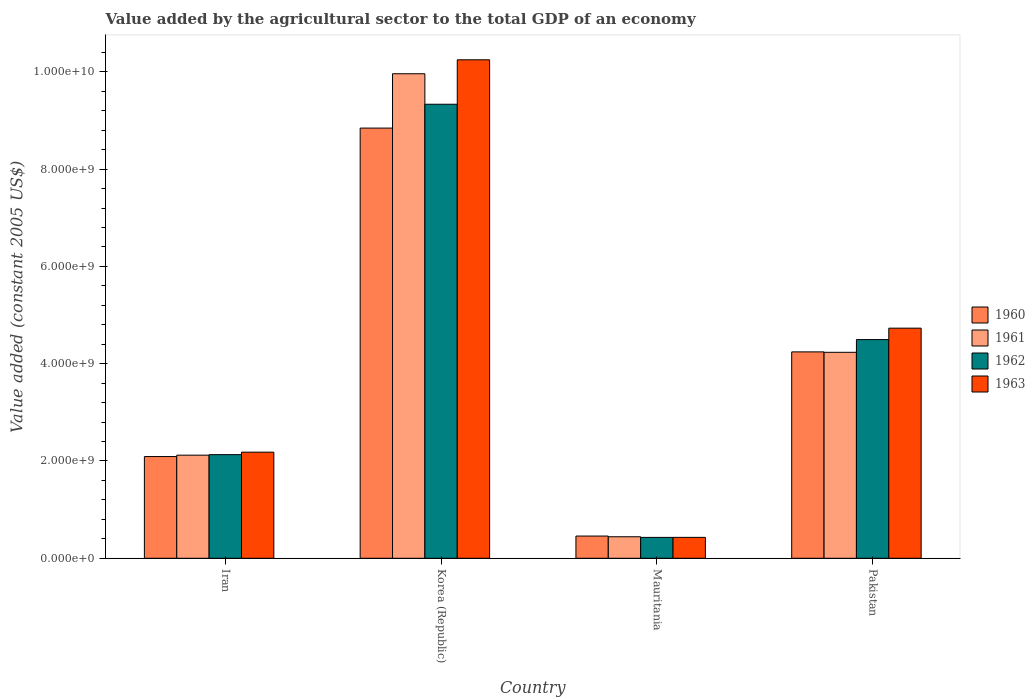Are the number of bars per tick equal to the number of legend labels?
Your answer should be compact. Yes. Are the number of bars on each tick of the X-axis equal?
Your answer should be very brief. Yes. How many bars are there on the 3rd tick from the left?
Give a very brief answer. 4. What is the value added by the agricultural sector in 1961 in Korea (Republic)?
Provide a succinct answer. 9.96e+09. Across all countries, what is the maximum value added by the agricultural sector in 1963?
Your response must be concise. 1.02e+1. Across all countries, what is the minimum value added by the agricultural sector in 1961?
Your answer should be very brief. 4.42e+08. In which country was the value added by the agricultural sector in 1963 minimum?
Give a very brief answer. Mauritania. What is the total value added by the agricultural sector in 1961 in the graph?
Make the answer very short. 1.68e+1. What is the difference between the value added by the agricultural sector in 1962 in Korea (Republic) and that in Mauritania?
Make the answer very short. 8.91e+09. What is the difference between the value added by the agricultural sector in 1962 in Pakistan and the value added by the agricultural sector in 1960 in Iran?
Your answer should be very brief. 2.40e+09. What is the average value added by the agricultural sector in 1960 per country?
Give a very brief answer. 3.91e+09. What is the difference between the value added by the agricultural sector of/in 1960 and value added by the agricultural sector of/in 1961 in Mauritania?
Make the answer very short. 1.44e+07. What is the ratio of the value added by the agricultural sector in 1960 in Korea (Republic) to that in Pakistan?
Your answer should be compact. 2.08. Is the difference between the value added by the agricultural sector in 1960 in Iran and Mauritania greater than the difference between the value added by the agricultural sector in 1961 in Iran and Mauritania?
Offer a very short reply. No. What is the difference between the highest and the second highest value added by the agricultural sector in 1963?
Your answer should be compact. 5.52e+09. What is the difference between the highest and the lowest value added by the agricultural sector in 1961?
Your response must be concise. 9.52e+09. In how many countries, is the value added by the agricultural sector in 1962 greater than the average value added by the agricultural sector in 1962 taken over all countries?
Keep it short and to the point. 2. Is the sum of the value added by the agricultural sector in 1962 in Iran and Mauritania greater than the maximum value added by the agricultural sector in 1963 across all countries?
Make the answer very short. No. Is it the case that in every country, the sum of the value added by the agricultural sector in 1960 and value added by the agricultural sector in 1961 is greater than the sum of value added by the agricultural sector in 1962 and value added by the agricultural sector in 1963?
Offer a very short reply. No. Is it the case that in every country, the sum of the value added by the agricultural sector in 1961 and value added by the agricultural sector in 1962 is greater than the value added by the agricultural sector in 1963?
Your response must be concise. Yes. How many bars are there?
Your answer should be compact. 16. What is the difference between two consecutive major ticks on the Y-axis?
Provide a succinct answer. 2.00e+09. Are the values on the major ticks of Y-axis written in scientific E-notation?
Provide a short and direct response. Yes. Does the graph contain any zero values?
Ensure brevity in your answer.  No. Does the graph contain grids?
Ensure brevity in your answer.  No. How are the legend labels stacked?
Keep it short and to the point. Vertical. What is the title of the graph?
Keep it short and to the point. Value added by the agricultural sector to the total GDP of an economy. Does "1967" appear as one of the legend labels in the graph?
Make the answer very short. No. What is the label or title of the Y-axis?
Your answer should be compact. Value added (constant 2005 US$). What is the Value added (constant 2005 US$) in 1960 in Iran?
Offer a very short reply. 2.09e+09. What is the Value added (constant 2005 US$) of 1961 in Iran?
Provide a short and direct response. 2.12e+09. What is the Value added (constant 2005 US$) of 1962 in Iran?
Give a very brief answer. 2.13e+09. What is the Value added (constant 2005 US$) of 1963 in Iran?
Offer a terse response. 2.18e+09. What is the Value added (constant 2005 US$) in 1960 in Korea (Republic)?
Keep it short and to the point. 8.84e+09. What is the Value added (constant 2005 US$) in 1961 in Korea (Republic)?
Ensure brevity in your answer.  9.96e+09. What is the Value added (constant 2005 US$) in 1962 in Korea (Republic)?
Offer a very short reply. 9.33e+09. What is the Value added (constant 2005 US$) in 1963 in Korea (Republic)?
Ensure brevity in your answer.  1.02e+1. What is the Value added (constant 2005 US$) in 1960 in Mauritania?
Your answer should be compact. 4.57e+08. What is the Value added (constant 2005 US$) of 1961 in Mauritania?
Keep it short and to the point. 4.42e+08. What is the Value added (constant 2005 US$) of 1962 in Mauritania?
Keep it short and to the point. 4.29e+08. What is the Value added (constant 2005 US$) of 1963 in Mauritania?
Offer a very short reply. 4.30e+08. What is the Value added (constant 2005 US$) of 1960 in Pakistan?
Provide a succinct answer. 4.24e+09. What is the Value added (constant 2005 US$) in 1961 in Pakistan?
Provide a short and direct response. 4.23e+09. What is the Value added (constant 2005 US$) in 1962 in Pakistan?
Offer a terse response. 4.50e+09. What is the Value added (constant 2005 US$) of 1963 in Pakistan?
Provide a short and direct response. 4.73e+09. Across all countries, what is the maximum Value added (constant 2005 US$) in 1960?
Ensure brevity in your answer.  8.84e+09. Across all countries, what is the maximum Value added (constant 2005 US$) of 1961?
Provide a succinct answer. 9.96e+09. Across all countries, what is the maximum Value added (constant 2005 US$) in 1962?
Provide a succinct answer. 9.33e+09. Across all countries, what is the maximum Value added (constant 2005 US$) of 1963?
Provide a short and direct response. 1.02e+1. Across all countries, what is the minimum Value added (constant 2005 US$) in 1960?
Give a very brief answer. 4.57e+08. Across all countries, what is the minimum Value added (constant 2005 US$) in 1961?
Provide a succinct answer. 4.42e+08. Across all countries, what is the minimum Value added (constant 2005 US$) of 1962?
Your answer should be very brief. 4.29e+08. Across all countries, what is the minimum Value added (constant 2005 US$) of 1963?
Your answer should be very brief. 4.30e+08. What is the total Value added (constant 2005 US$) in 1960 in the graph?
Provide a succinct answer. 1.56e+1. What is the total Value added (constant 2005 US$) in 1961 in the graph?
Your answer should be compact. 1.68e+1. What is the total Value added (constant 2005 US$) of 1962 in the graph?
Give a very brief answer. 1.64e+1. What is the total Value added (constant 2005 US$) of 1963 in the graph?
Ensure brevity in your answer.  1.76e+1. What is the difference between the Value added (constant 2005 US$) in 1960 in Iran and that in Korea (Republic)?
Make the answer very short. -6.75e+09. What is the difference between the Value added (constant 2005 US$) of 1961 in Iran and that in Korea (Republic)?
Give a very brief answer. -7.84e+09. What is the difference between the Value added (constant 2005 US$) of 1962 in Iran and that in Korea (Republic)?
Offer a terse response. -7.20e+09. What is the difference between the Value added (constant 2005 US$) of 1963 in Iran and that in Korea (Republic)?
Provide a short and direct response. -8.07e+09. What is the difference between the Value added (constant 2005 US$) of 1960 in Iran and that in Mauritania?
Make the answer very short. 1.63e+09. What is the difference between the Value added (constant 2005 US$) of 1961 in Iran and that in Mauritania?
Offer a terse response. 1.68e+09. What is the difference between the Value added (constant 2005 US$) of 1962 in Iran and that in Mauritania?
Make the answer very short. 1.70e+09. What is the difference between the Value added (constant 2005 US$) of 1963 in Iran and that in Mauritania?
Provide a short and direct response. 1.75e+09. What is the difference between the Value added (constant 2005 US$) in 1960 in Iran and that in Pakistan?
Make the answer very short. -2.15e+09. What is the difference between the Value added (constant 2005 US$) of 1961 in Iran and that in Pakistan?
Ensure brevity in your answer.  -2.11e+09. What is the difference between the Value added (constant 2005 US$) in 1962 in Iran and that in Pakistan?
Your response must be concise. -2.37e+09. What is the difference between the Value added (constant 2005 US$) of 1963 in Iran and that in Pakistan?
Your answer should be compact. -2.55e+09. What is the difference between the Value added (constant 2005 US$) in 1960 in Korea (Republic) and that in Mauritania?
Make the answer very short. 8.39e+09. What is the difference between the Value added (constant 2005 US$) of 1961 in Korea (Republic) and that in Mauritania?
Your answer should be compact. 9.52e+09. What is the difference between the Value added (constant 2005 US$) in 1962 in Korea (Republic) and that in Mauritania?
Make the answer very short. 8.91e+09. What is the difference between the Value added (constant 2005 US$) in 1963 in Korea (Republic) and that in Mauritania?
Give a very brief answer. 9.82e+09. What is the difference between the Value added (constant 2005 US$) of 1960 in Korea (Republic) and that in Pakistan?
Your answer should be very brief. 4.60e+09. What is the difference between the Value added (constant 2005 US$) in 1961 in Korea (Republic) and that in Pakistan?
Offer a terse response. 5.73e+09. What is the difference between the Value added (constant 2005 US$) of 1962 in Korea (Republic) and that in Pakistan?
Keep it short and to the point. 4.84e+09. What is the difference between the Value added (constant 2005 US$) of 1963 in Korea (Republic) and that in Pakistan?
Keep it short and to the point. 5.52e+09. What is the difference between the Value added (constant 2005 US$) of 1960 in Mauritania and that in Pakistan?
Ensure brevity in your answer.  -3.79e+09. What is the difference between the Value added (constant 2005 US$) in 1961 in Mauritania and that in Pakistan?
Your answer should be very brief. -3.79e+09. What is the difference between the Value added (constant 2005 US$) of 1962 in Mauritania and that in Pakistan?
Your response must be concise. -4.07e+09. What is the difference between the Value added (constant 2005 US$) in 1963 in Mauritania and that in Pakistan?
Give a very brief answer. -4.30e+09. What is the difference between the Value added (constant 2005 US$) of 1960 in Iran and the Value added (constant 2005 US$) of 1961 in Korea (Republic)?
Provide a succinct answer. -7.87e+09. What is the difference between the Value added (constant 2005 US$) of 1960 in Iran and the Value added (constant 2005 US$) of 1962 in Korea (Republic)?
Offer a terse response. -7.24e+09. What is the difference between the Value added (constant 2005 US$) of 1960 in Iran and the Value added (constant 2005 US$) of 1963 in Korea (Republic)?
Your answer should be very brief. -8.16e+09. What is the difference between the Value added (constant 2005 US$) in 1961 in Iran and the Value added (constant 2005 US$) in 1962 in Korea (Republic)?
Your response must be concise. -7.21e+09. What is the difference between the Value added (constant 2005 US$) in 1961 in Iran and the Value added (constant 2005 US$) in 1963 in Korea (Republic)?
Ensure brevity in your answer.  -8.13e+09. What is the difference between the Value added (constant 2005 US$) in 1962 in Iran and the Value added (constant 2005 US$) in 1963 in Korea (Republic)?
Your answer should be very brief. -8.12e+09. What is the difference between the Value added (constant 2005 US$) in 1960 in Iran and the Value added (constant 2005 US$) in 1961 in Mauritania?
Your answer should be very brief. 1.65e+09. What is the difference between the Value added (constant 2005 US$) in 1960 in Iran and the Value added (constant 2005 US$) in 1962 in Mauritania?
Offer a terse response. 1.66e+09. What is the difference between the Value added (constant 2005 US$) of 1960 in Iran and the Value added (constant 2005 US$) of 1963 in Mauritania?
Make the answer very short. 1.66e+09. What is the difference between the Value added (constant 2005 US$) in 1961 in Iran and the Value added (constant 2005 US$) in 1962 in Mauritania?
Your answer should be very brief. 1.69e+09. What is the difference between the Value added (constant 2005 US$) in 1961 in Iran and the Value added (constant 2005 US$) in 1963 in Mauritania?
Your response must be concise. 1.69e+09. What is the difference between the Value added (constant 2005 US$) in 1962 in Iran and the Value added (constant 2005 US$) in 1963 in Mauritania?
Offer a terse response. 1.70e+09. What is the difference between the Value added (constant 2005 US$) in 1960 in Iran and the Value added (constant 2005 US$) in 1961 in Pakistan?
Give a very brief answer. -2.14e+09. What is the difference between the Value added (constant 2005 US$) of 1960 in Iran and the Value added (constant 2005 US$) of 1962 in Pakistan?
Give a very brief answer. -2.40e+09. What is the difference between the Value added (constant 2005 US$) in 1960 in Iran and the Value added (constant 2005 US$) in 1963 in Pakistan?
Offer a very short reply. -2.64e+09. What is the difference between the Value added (constant 2005 US$) of 1961 in Iran and the Value added (constant 2005 US$) of 1962 in Pakistan?
Your answer should be compact. -2.38e+09. What is the difference between the Value added (constant 2005 US$) in 1961 in Iran and the Value added (constant 2005 US$) in 1963 in Pakistan?
Your response must be concise. -2.61e+09. What is the difference between the Value added (constant 2005 US$) of 1962 in Iran and the Value added (constant 2005 US$) of 1963 in Pakistan?
Provide a short and direct response. -2.60e+09. What is the difference between the Value added (constant 2005 US$) in 1960 in Korea (Republic) and the Value added (constant 2005 US$) in 1961 in Mauritania?
Your answer should be compact. 8.40e+09. What is the difference between the Value added (constant 2005 US$) of 1960 in Korea (Republic) and the Value added (constant 2005 US$) of 1962 in Mauritania?
Your answer should be compact. 8.41e+09. What is the difference between the Value added (constant 2005 US$) in 1960 in Korea (Republic) and the Value added (constant 2005 US$) in 1963 in Mauritania?
Keep it short and to the point. 8.41e+09. What is the difference between the Value added (constant 2005 US$) in 1961 in Korea (Republic) and the Value added (constant 2005 US$) in 1962 in Mauritania?
Your answer should be very brief. 9.53e+09. What is the difference between the Value added (constant 2005 US$) in 1961 in Korea (Republic) and the Value added (constant 2005 US$) in 1963 in Mauritania?
Your response must be concise. 9.53e+09. What is the difference between the Value added (constant 2005 US$) in 1962 in Korea (Republic) and the Value added (constant 2005 US$) in 1963 in Mauritania?
Your answer should be very brief. 8.90e+09. What is the difference between the Value added (constant 2005 US$) of 1960 in Korea (Republic) and the Value added (constant 2005 US$) of 1961 in Pakistan?
Provide a succinct answer. 4.61e+09. What is the difference between the Value added (constant 2005 US$) in 1960 in Korea (Republic) and the Value added (constant 2005 US$) in 1962 in Pakistan?
Offer a very short reply. 4.35e+09. What is the difference between the Value added (constant 2005 US$) of 1960 in Korea (Republic) and the Value added (constant 2005 US$) of 1963 in Pakistan?
Provide a succinct answer. 4.11e+09. What is the difference between the Value added (constant 2005 US$) of 1961 in Korea (Republic) and the Value added (constant 2005 US$) of 1962 in Pakistan?
Your answer should be very brief. 5.46e+09. What is the difference between the Value added (constant 2005 US$) in 1961 in Korea (Republic) and the Value added (constant 2005 US$) in 1963 in Pakistan?
Provide a succinct answer. 5.23e+09. What is the difference between the Value added (constant 2005 US$) of 1962 in Korea (Republic) and the Value added (constant 2005 US$) of 1963 in Pakistan?
Offer a very short reply. 4.60e+09. What is the difference between the Value added (constant 2005 US$) in 1960 in Mauritania and the Value added (constant 2005 US$) in 1961 in Pakistan?
Provide a succinct answer. -3.78e+09. What is the difference between the Value added (constant 2005 US$) of 1960 in Mauritania and the Value added (constant 2005 US$) of 1962 in Pakistan?
Keep it short and to the point. -4.04e+09. What is the difference between the Value added (constant 2005 US$) of 1960 in Mauritania and the Value added (constant 2005 US$) of 1963 in Pakistan?
Offer a terse response. -4.27e+09. What is the difference between the Value added (constant 2005 US$) in 1961 in Mauritania and the Value added (constant 2005 US$) in 1962 in Pakistan?
Provide a succinct answer. -4.05e+09. What is the difference between the Value added (constant 2005 US$) in 1961 in Mauritania and the Value added (constant 2005 US$) in 1963 in Pakistan?
Your answer should be very brief. -4.29e+09. What is the difference between the Value added (constant 2005 US$) of 1962 in Mauritania and the Value added (constant 2005 US$) of 1963 in Pakistan?
Make the answer very short. -4.30e+09. What is the average Value added (constant 2005 US$) of 1960 per country?
Your answer should be very brief. 3.91e+09. What is the average Value added (constant 2005 US$) in 1961 per country?
Give a very brief answer. 4.19e+09. What is the average Value added (constant 2005 US$) of 1962 per country?
Offer a very short reply. 4.10e+09. What is the average Value added (constant 2005 US$) of 1963 per country?
Offer a very short reply. 4.40e+09. What is the difference between the Value added (constant 2005 US$) of 1960 and Value added (constant 2005 US$) of 1961 in Iran?
Your answer should be very brief. -2.84e+07. What is the difference between the Value added (constant 2005 US$) in 1960 and Value added (constant 2005 US$) in 1962 in Iran?
Give a very brief answer. -3.89e+07. What is the difference between the Value added (constant 2005 US$) of 1960 and Value added (constant 2005 US$) of 1963 in Iran?
Your response must be concise. -9.02e+07. What is the difference between the Value added (constant 2005 US$) in 1961 and Value added (constant 2005 US$) in 1962 in Iran?
Your answer should be compact. -1.05e+07. What is the difference between the Value added (constant 2005 US$) of 1961 and Value added (constant 2005 US$) of 1963 in Iran?
Ensure brevity in your answer.  -6.18e+07. What is the difference between the Value added (constant 2005 US$) in 1962 and Value added (constant 2005 US$) in 1963 in Iran?
Make the answer very short. -5.13e+07. What is the difference between the Value added (constant 2005 US$) in 1960 and Value added (constant 2005 US$) in 1961 in Korea (Republic)?
Your answer should be very brief. -1.12e+09. What is the difference between the Value added (constant 2005 US$) of 1960 and Value added (constant 2005 US$) of 1962 in Korea (Republic)?
Offer a very short reply. -4.90e+08. What is the difference between the Value added (constant 2005 US$) in 1960 and Value added (constant 2005 US$) in 1963 in Korea (Republic)?
Provide a succinct answer. -1.40e+09. What is the difference between the Value added (constant 2005 US$) in 1961 and Value added (constant 2005 US$) in 1962 in Korea (Republic)?
Your answer should be very brief. 6.27e+08. What is the difference between the Value added (constant 2005 US$) in 1961 and Value added (constant 2005 US$) in 1963 in Korea (Republic)?
Your answer should be compact. -2.87e+08. What is the difference between the Value added (constant 2005 US$) in 1962 and Value added (constant 2005 US$) in 1963 in Korea (Republic)?
Keep it short and to the point. -9.14e+08. What is the difference between the Value added (constant 2005 US$) of 1960 and Value added (constant 2005 US$) of 1961 in Mauritania?
Provide a succinct answer. 1.44e+07. What is the difference between the Value added (constant 2005 US$) of 1960 and Value added (constant 2005 US$) of 1962 in Mauritania?
Offer a terse response. 2.75e+07. What is the difference between the Value added (constant 2005 US$) in 1960 and Value added (constant 2005 US$) in 1963 in Mauritania?
Make the answer very short. 2.68e+07. What is the difference between the Value added (constant 2005 US$) of 1961 and Value added (constant 2005 US$) of 1962 in Mauritania?
Your response must be concise. 1.31e+07. What is the difference between the Value added (constant 2005 US$) of 1961 and Value added (constant 2005 US$) of 1963 in Mauritania?
Provide a short and direct response. 1.24e+07. What is the difference between the Value added (constant 2005 US$) in 1962 and Value added (constant 2005 US$) in 1963 in Mauritania?
Provide a short and direct response. -7.06e+05. What is the difference between the Value added (constant 2005 US$) in 1960 and Value added (constant 2005 US$) in 1961 in Pakistan?
Your answer should be very brief. 8.56e+06. What is the difference between the Value added (constant 2005 US$) of 1960 and Value added (constant 2005 US$) of 1962 in Pakistan?
Give a very brief answer. -2.53e+08. What is the difference between the Value added (constant 2005 US$) of 1960 and Value added (constant 2005 US$) of 1963 in Pakistan?
Ensure brevity in your answer.  -4.87e+08. What is the difference between the Value added (constant 2005 US$) of 1961 and Value added (constant 2005 US$) of 1962 in Pakistan?
Provide a succinct answer. -2.62e+08. What is the difference between the Value added (constant 2005 US$) of 1961 and Value added (constant 2005 US$) of 1963 in Pakistan?
Keep it short and to the point. -4.96e+08. What is the difference between the Value added (constant 2005 US$) in 1962 and Value added (constant 2005 US$) in 1963 in Pakistan?
Provide a succinct answer. -2.34e+08. What is the ratio of the Value added (constant 2005 US$) of 1960 in Iran to that in Korea (Republic)?
Your response must be concise. 0.24. What is the ratio of the Value added (constant 2005 US$) in 1961 in Iran to that in Korea (Republic)?
Offer a very short reply. 0.21. What is the ratio of the Value added (constant 2005 US$) of 1962 in Iran to that in Korea (Republic)?
Give a very brief answer. 0.23. What is the ratio of the Value added (constant 2005 US$) of 1963 in Iran to that in Korea (Republic)?
Provide a short and direct response. 0.21. What is the ratio of the Value added (constant 2005 US$) in 1960 in Iran to that in Mauritania?
Provide a short and direct response. 4.58. What is the ratio of the Value added (constant 2005 US$) in 1961 in Iran to that in Mauritania?
Offer a very short reply. 4.79. What is the ratio of the Value added (constant 2005 US$) of 1962 in Iran to that in Mauritania?
Your answer should be very brief. 4.96. What is the ratio of the Value added (constant 2005 US$) in 1963 in Iran to that in Mauritania?
Keep it short and to the point. 5.07. What is the ratio of the Value added (constant 2005 US$) in 1960 in Iran to that in Pakistan?
Your response must be concise. 0.49. What is the ratio of the Value added (constant 2005 US$) of 1961 in Iran to that in Pakistan?
Make the answer very short. 0.5. What is the ratio of the Value added (constant 2005 US$) in 1962 in Iran to that in Pakistan?
Keep it short and to the point. 0.47. What is the ratio of the Value added (constant 2005 US$) of 1963 in Iran to that in Pakistan?
Your answer should be compact. 0.46. What is the ratio of the Value added (constant 2005 US$) of 1960 in Korea (Republic) to that in Mauritania?
Provide a succinct answer. 19.37. What is the ratio of the Value added (constant 2005 US$) of 1961 in Korea (Republic) to that in Mauritania?
Your answer should be compact. 22.52. What is the ratio of the Value added (constant 2005 US$) in 1962 in Korea (Republic) to that in Mauritania?
Your response must be concise. 21.75. What is the ratio of the Value added (constant 2005 US$) in 1963 in Korea (Republic) to that in Mauritania?
Offer a terse response. 23.84. What is the ratio of the Value added (constant 2005 US$) in 1960 in Korea (Republic) to that in Pakistan?
Keep it short and to the point. 2.08. What is the ratio of the Value added (constant 2005 US$) in 1961 in Korea (Republic) to that in Pakistan?
Make the answer very short. 2.35. What is the ratio of the Value added (constant 2005 US$) in 1962 in Korea (Republic) to that in Pakistan?
Give a very brief answer. 2.08. What is the ratio of the Value added (constant 2005 US$) in 1963 in Korea (Republic) to that in Pakistan?
Provide a short and direct response. 2.17. What is the ratio of the Value added (constant 2005 US$) in 1960 in Mauritania to that in Pakistan?
Your response must be concise. 0.11. What is the ratio of the Value added (constant 2005 US$) in 1961 in Mauritania to that in Pakistan?
Provide a short and direct response. 0.1. What is the ratio of the Value added (constant 2005 US$) of 1962 in Mauritania to that in Pakistan?
Give a very brief answer. 0.1. What is the ratio of the Value added (constant 2005 US$) in 1963 in Mauritania to that in Pakistan?
Offer a terse response. 0.09. What is the difference between the highest and the second highest Value added (constant 2005 US$) in 1960?
Offer a terse response. 4.60e+09. What is the difference between the highest and the second highest Value added (constant 2005 US$) in 1961?
Your answer should be very brief. 5.73e+09. What is the difference between the highest and the second highest Value added (constant 2005 US$) in 1962?
Give a very brief answer. 4.84e+09. What is the difference between the highest and the second highest Value added (constant 2005 US$) in 1963?
Provide a succinct answer. 5.52e+09. What is the difference between the highest and the lowest Value added (constant 2005 US$) of 1960?
Keep it short and to the point. 8.39e+09. What is the difference between the highest and the lowest Value added (constant 2005 US$) of 1961?
Give a very brief answer. 9.52e+09. What is the difference between the highest and the lowest Value added (constant 2005 US$) in 1962?
Ensure brevity in your answer.  8.91e+09. What is the difference between the highest and the lowest Value added (constant 2005 US$) in 1963?
Your response must be concise. 9.82e+09. 